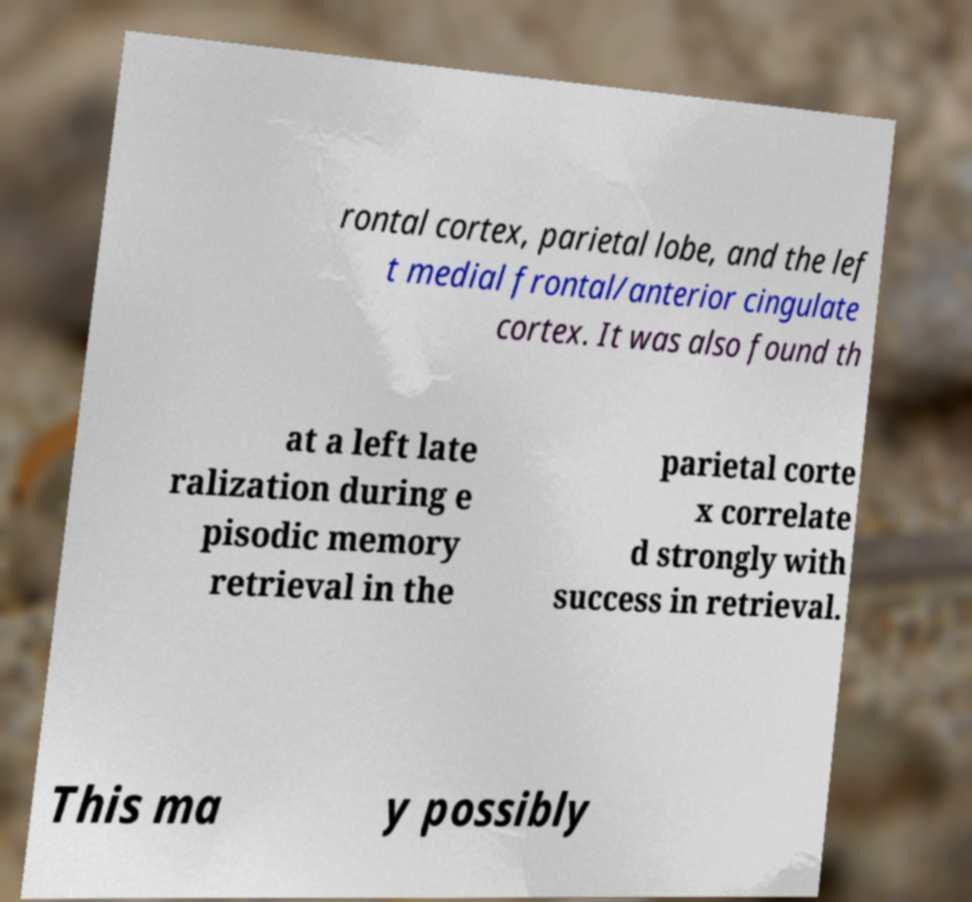Please identify and transcribe the text found in this image. rontal cortex, parietal lobe, and the lef t medial frontal/anterior cingulate cortex. It was also found th at a left late ralization during e pisodic memory retrieval in the parietal corte x correlate d strongly with success in retrieval. This ma y possibly 